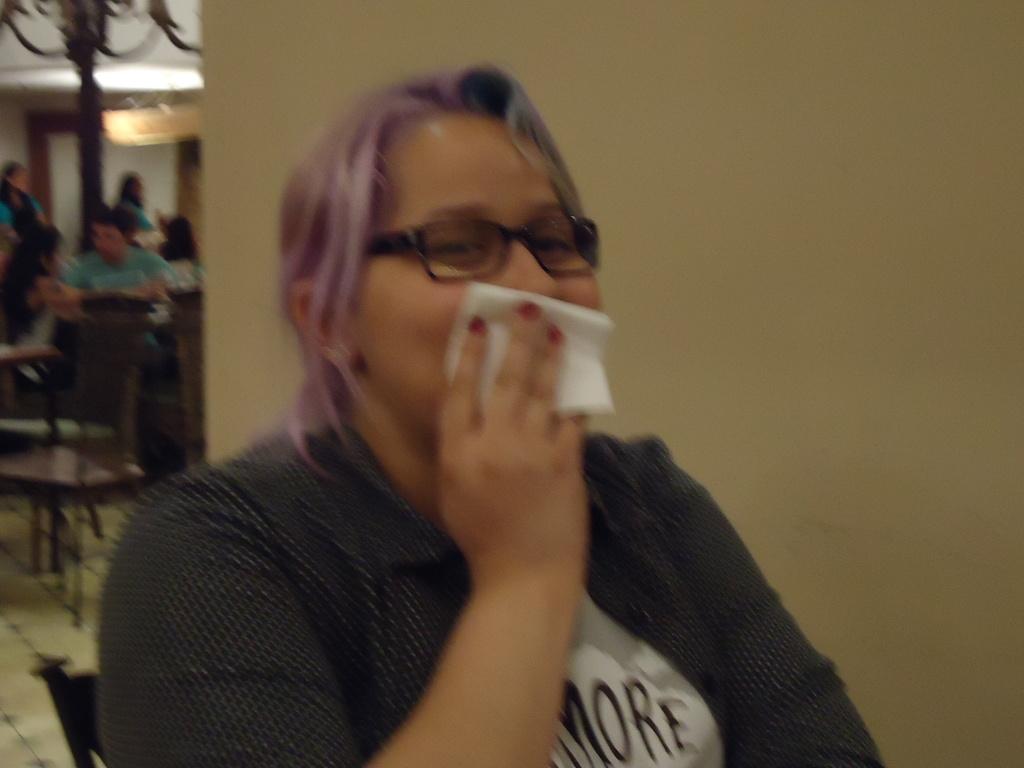Describe this image in one or two sentences. In this picture there is a lady in the center of the image and there are other people on the left side of the image. 